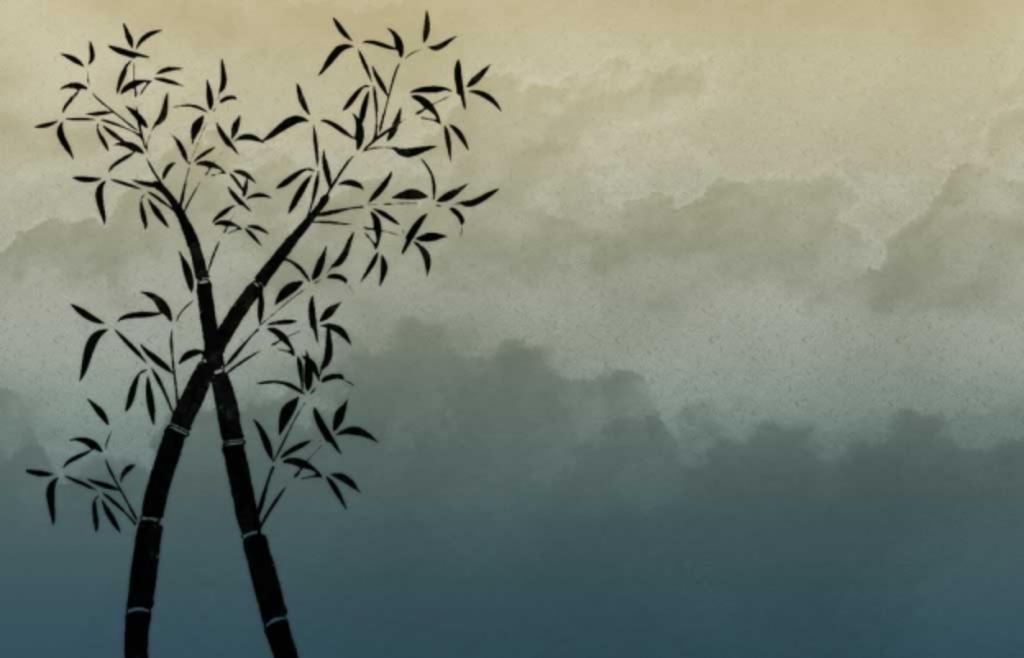What type of plant material is present in the image? There are leaves and stems in the image. What is the condition of the sky in the image? The sky is cloudy in the image. What type of wine is being poured from the wrist in the image? There is no wrist or wine present in the image; it features leaves and stems with a cloudy sky. 